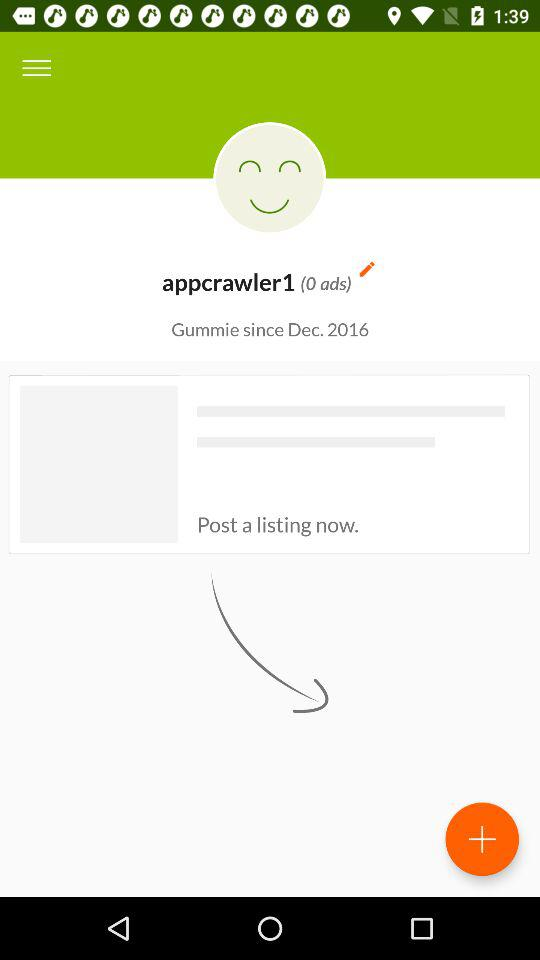How many ads are there? There are 0 ads. 